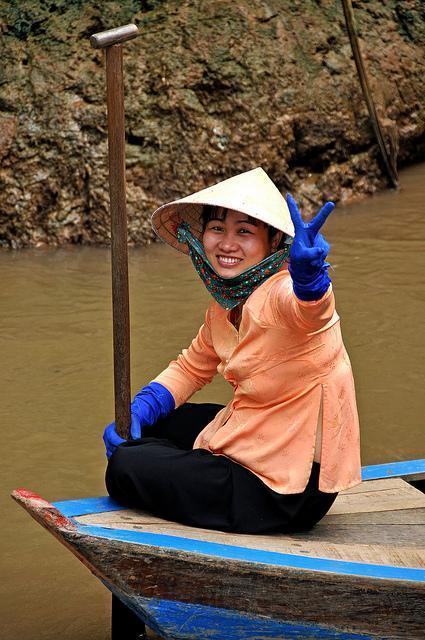How many people at the table are wearing tie dye?
Give a very brief answer. 0. 